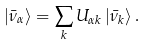Convert formula to latex. <formula><loc_0><loc_0><loc_500><loc_500>| \bar { \nu } _ { \alpha } \rangle = \sum _ { k } U _ { \alpha k } \, | \bar { \nu } _ { k } \rangle \, .</formula> 